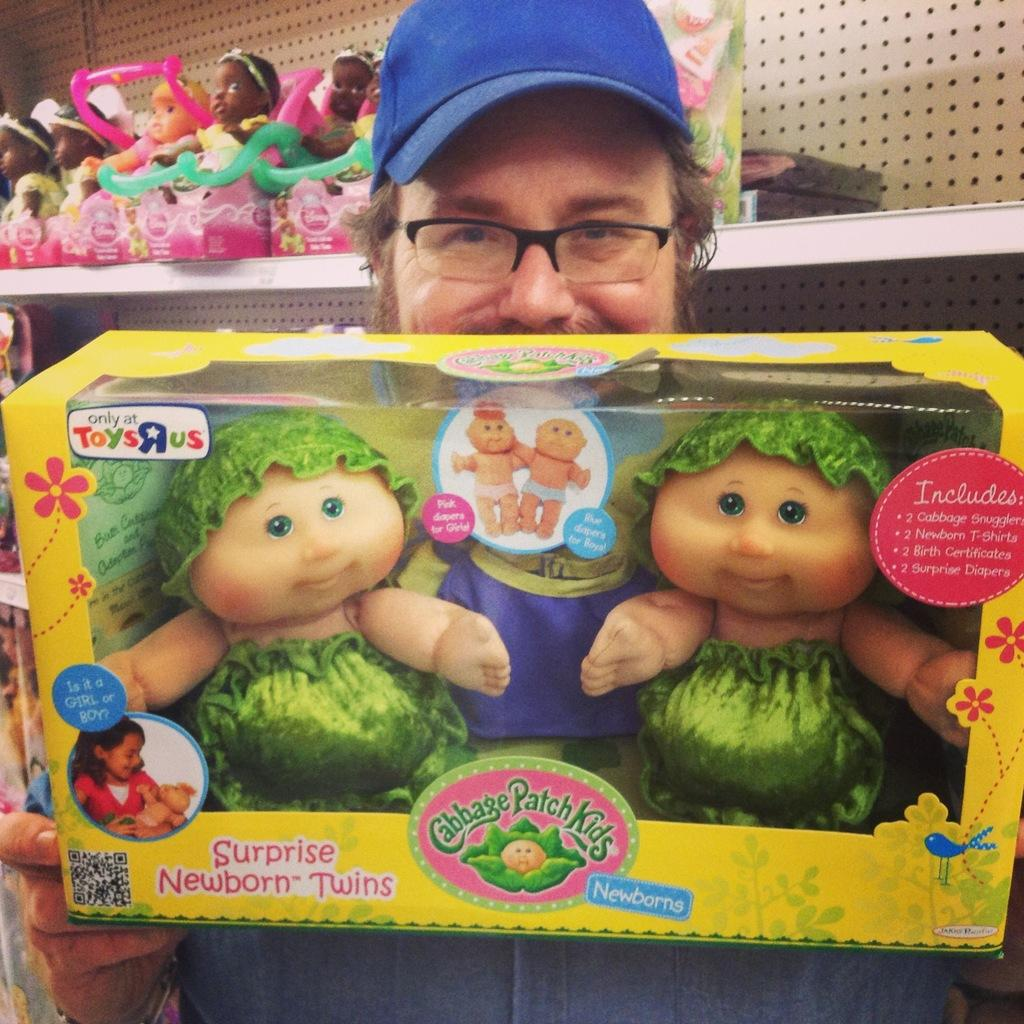What is the main subject of the image? There is a man standing in the center of the image. What is the man holding in the image? The man is holding a toy box. What can be seen in the background of the image? There are shelves in the background of the image. What is placed on the shelves? Toys are placed on the shelves. What type of flowers can be seen growing on the shelves in the image? There are no flowers present in the image. How many rabbits are visible on the shelves in the image? There are no rabbits present in the image. 